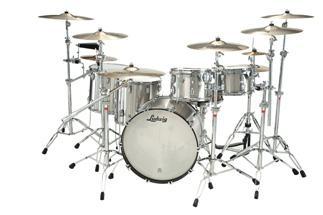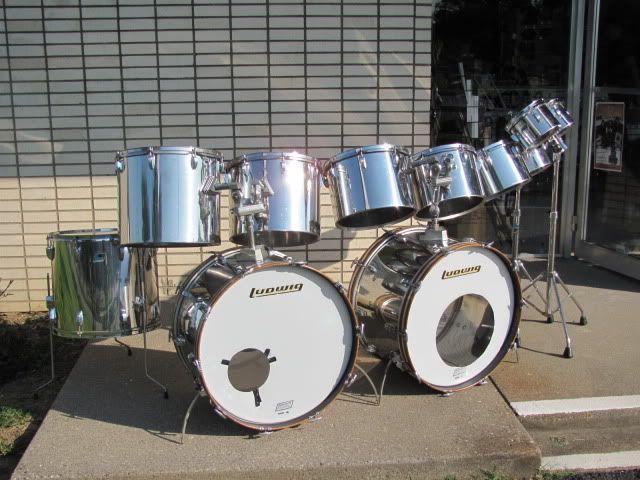The first image is the image on the left, the second image is the image on the right. Evaluate the accuracy of this statement regarding the images: "There are three kick drums.". Is it true? Answer yes or no. Yes. The first image is the image on the left, the second image is the image on the right. For the images shown, is this caption "The drum set on the left includes cymbals." true? Answer yes or no. Yes. 